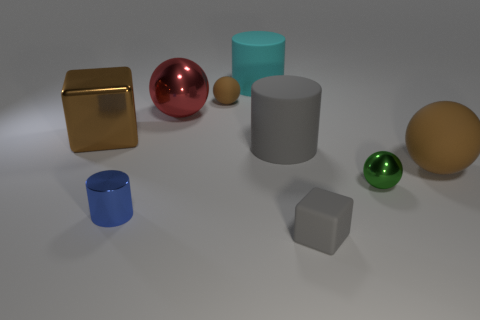How many other objects are the same color as the metallic block?
Provide a succinct answer. 2. How many things are either large metallic blocks or cubes that are to the left of the tiny brown rubber thing?
Offer a very short reply. 1. There is a cyan cylinder that is the same material as the gray block; what is its size?
Keep it short and to the point. Large. The rubber thing that is in front of the large rubber object right of the gray block is what shape?
Ensure brevity in your answer.  Cube. What is the size of the cylinder that is in front of the large cyan rubber cylinder and behind the blue thing?
Provide a short and direct response. Large. Is there a green shiny thing that has the same shape as the tiny gray matte thing?
Make the answer very short. No. Is there any other thing that has the same shape as the large red metallic object?
Provide a succinct answer. Yes. There is a block in front of the cylinder left of the rubber ball that is behind the large red metallic thing; what is its material?
Ensure brevity in your answer.  Rubber. Are there any red matte blocks of the same size as the green thing?
Offer a very short reply. No. What color is the big cylinder in front of the block left of the small block?
Provide a short and direct response. Gray. 